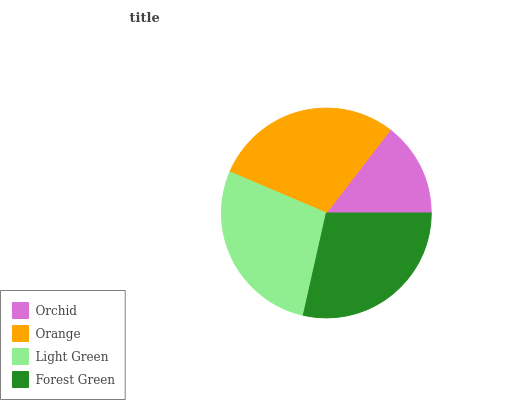Is Orchid the minimum?
Answer yes or no. Yes. Is Orange the maximum?
Answer yes or no. Yes. Is Light Green the minimum?
Answer yes or no. No. Is Light Green the maximum?
Answer yes or no. No. Is Orange greater than Light Green?
Answer yes or no. Yes. Is Light Green less than Orange?
Answer yes or no. Yes. Is Light Green greater than Orange?
Answer yes or no. No. Is Orange less than Light Green?
Answer yes or no. No. Is Forest Green the high median?
Answer yes or no. Yes. Is Light Green the low median?
Answer yes or no. Yes. Is Orchid the high median?
Answer yes or no. No. Is Orange the low median?
Answer yes or no. No. 